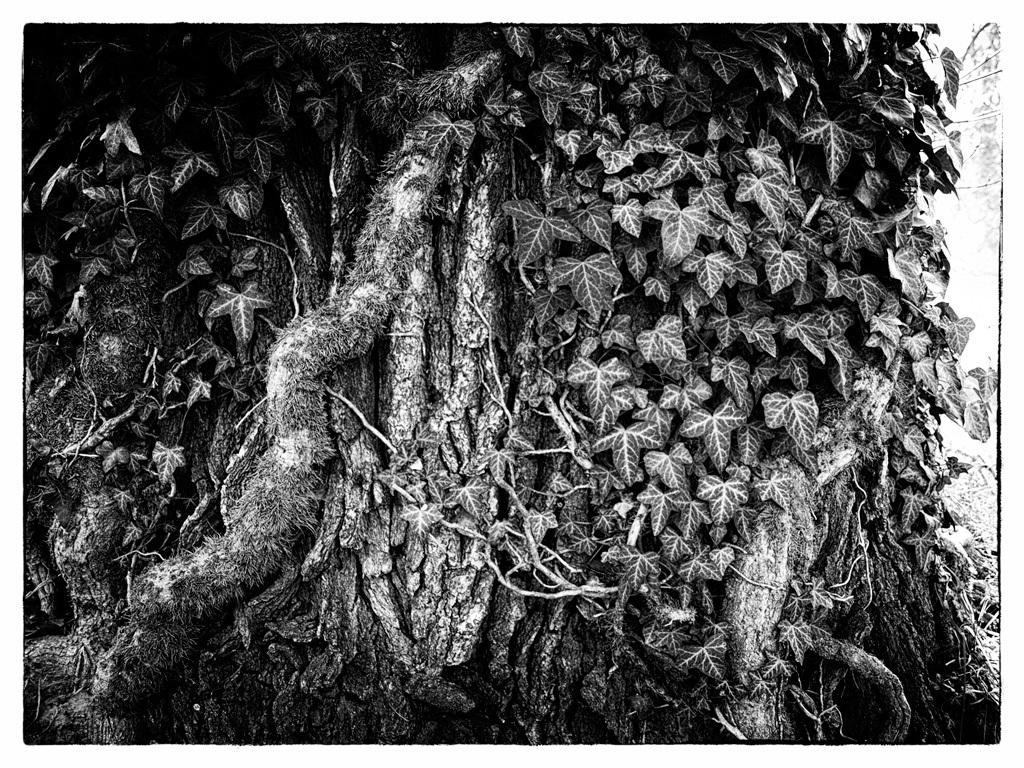What part of a tree is visible in the image? There is a bark of a tree in the image. What else can be seen on the tree in the image? There are leaves on the tree in the image. How does the tree express pain in the image? Trees do not express pain, as they are not sentient beings. 